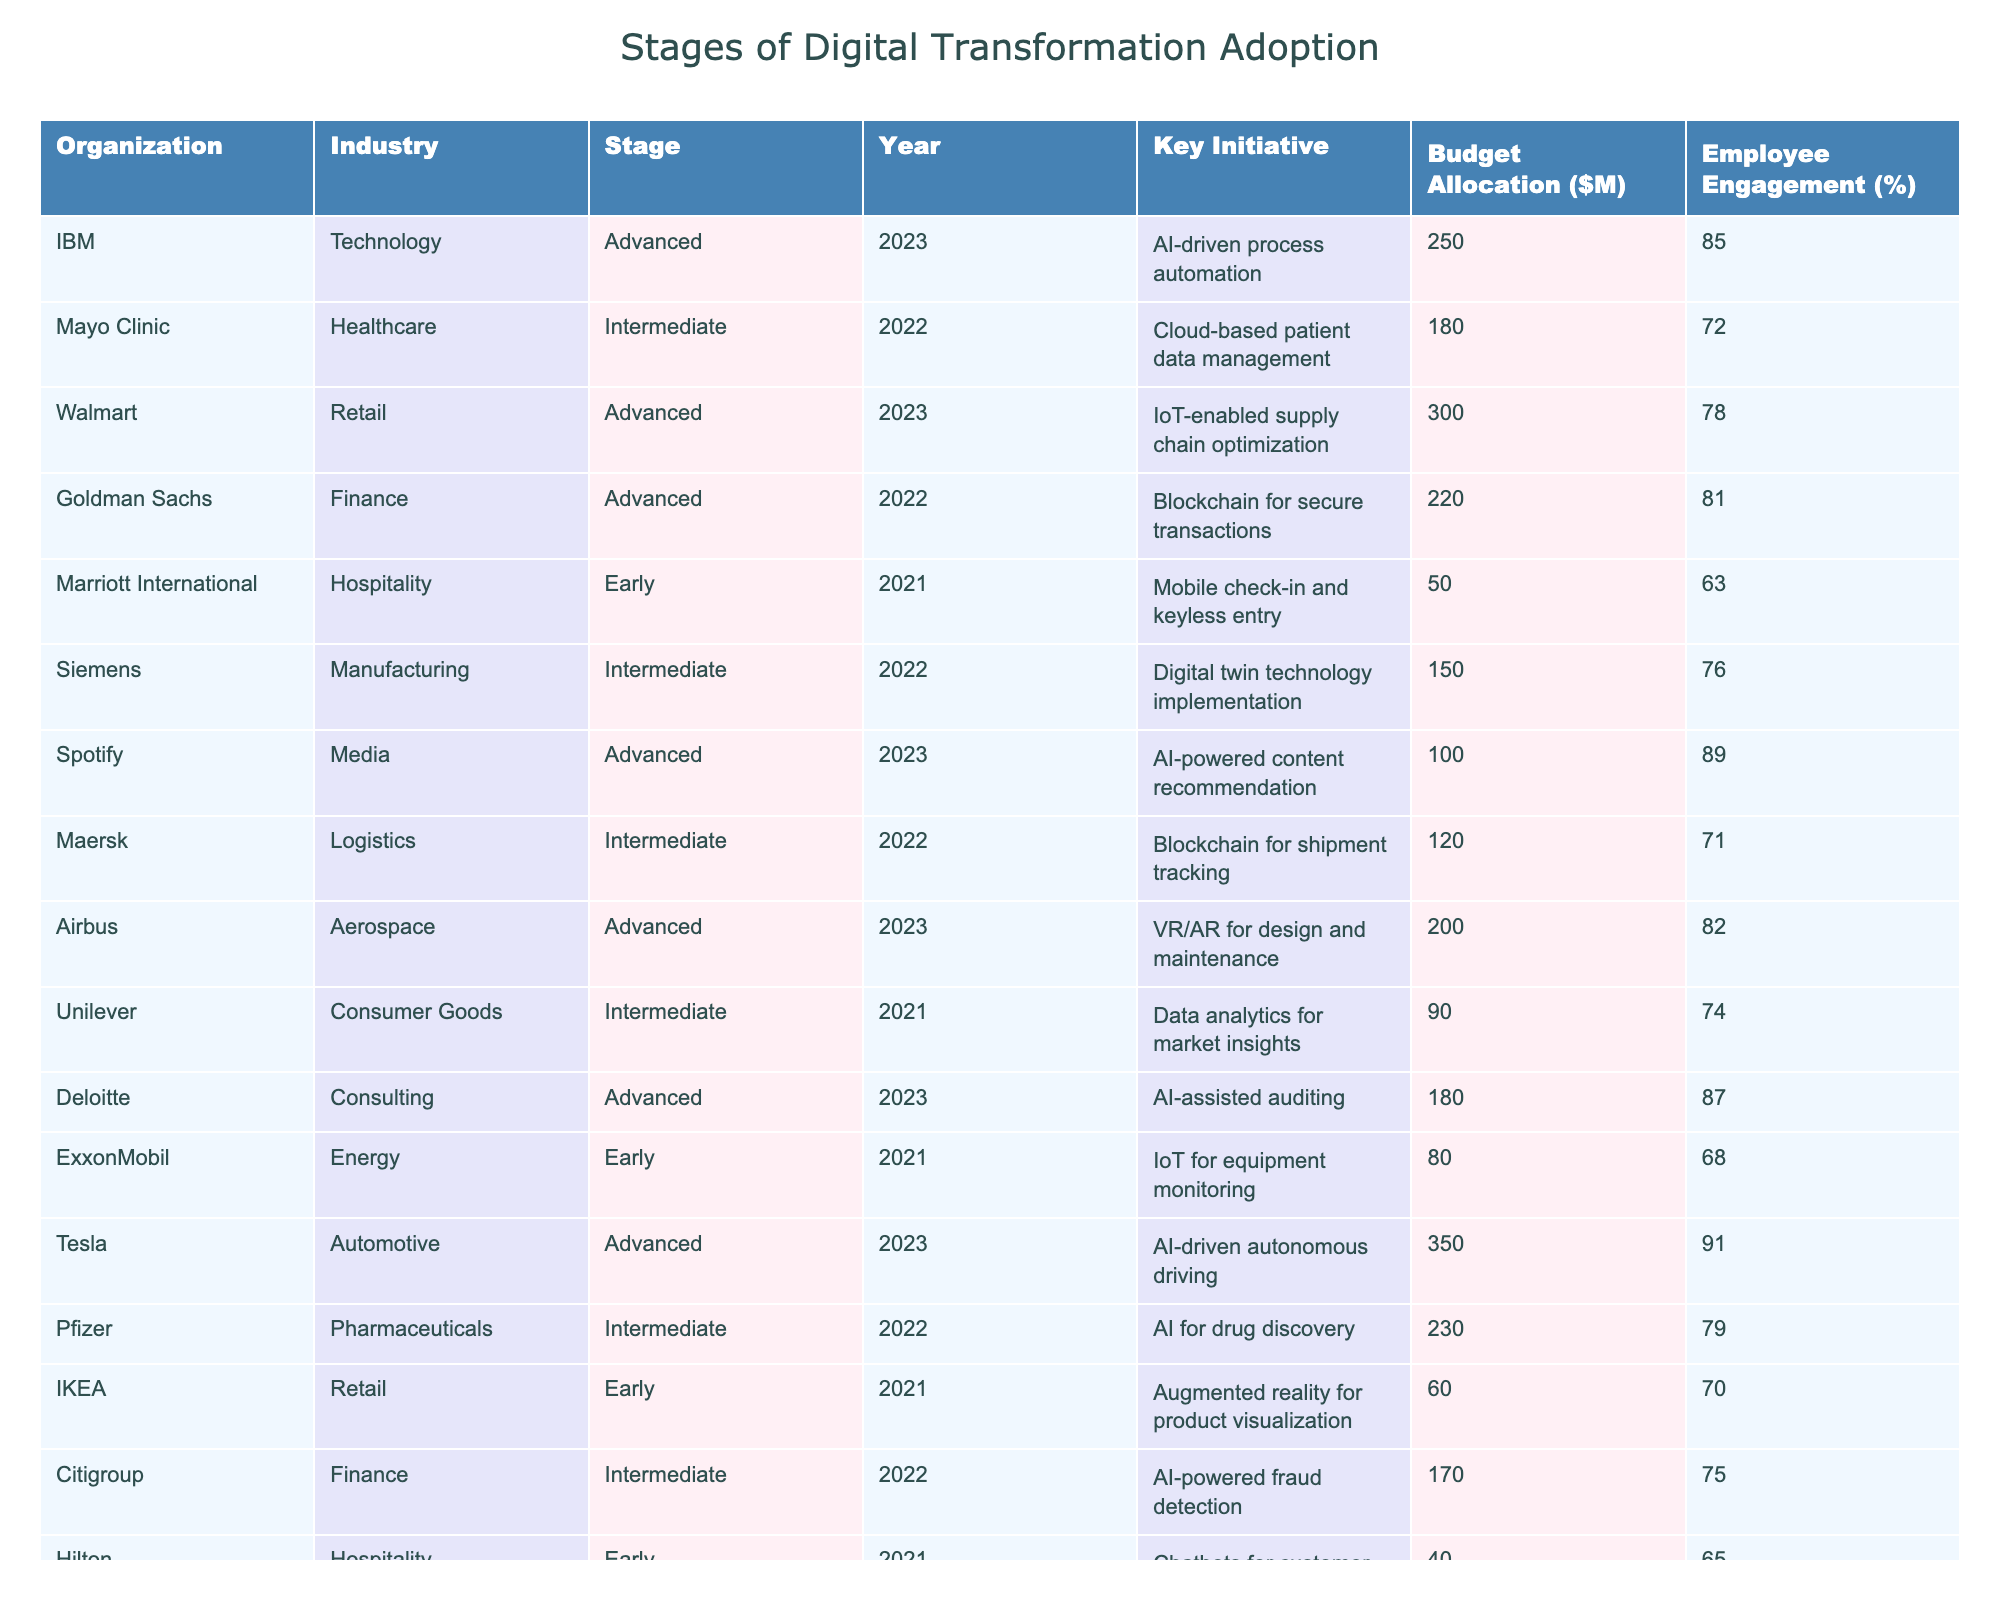What stage of digital transformation is IBM in? The table shows that IBM is classified under the "Advanced" stage of digital transformation adoption for the year 2023.
Answer: Advanced What key initiative is associated with Pfizer? According to the table, Pfizer's key initiative is "AI for drug discovery" and it falls under the Intermediate stage of digital transformation in 2022.
Answer: AI for drug discovery Which organization has the highest budget allocation for digital transformation in 2023? The table indicates that Tesla has the highest budget allocation of $350 million for their digital transformation initiative in 2023.
Answer: Tesla What is the average budget allocation across all organizations listed? To calculate the average, sum all budget allocations ($250M + $180M + ... + $280M = $1,525M) and divide by the total number of organizations (15). This results in an average budget allocation of $101.67 million.
Answer: 101.67 million Is there any organization in the Early stage of digital transformation with an employee engagement percentage above 70%? By checking the Early stage entries (Marriott International, ExxonMobil, IKEA, Hilton), we see that none have an employee engagement percentage exceeding 70%.
Answer: No What is the relationship between the stage of digital transformation and budget allocation based on this data? Analyzing the data, organizations in the Advanced stage tend to have higher budget allocations compared to those in Early and Intermediate stages, which indicates that advanced adopters are investing more in transformation initiatives.
Answer: Higher budget in Advanced stage Which industry has the most organizations in the Advanced stage? Looking through the table, the Technology and Finance industries each have three organizations in the Advanced stage.
Answer: Technology and Finance What is the median employee engagement percentage for organizations in the Intermediate stage? The employee engagement percentages for Intermediate stage organizations (72, 76, 71, 79, 75, 77) when sorted are 71, 72, 75, 76, 77, 79. The median of this set is the average of the middle two values (75 + 76) / 2 = 75.5.
Answer: 75.5 How many organizations in the Retail industry are in the Early stage? The table lists two organizations in the Retail industry (Walmart and IKEA), but only IKEA is in the Early stage.
Answer: One Which organization has the lowest employee engagement percentage and what is it? Upon reviewing the table, Hilton has the lowest employee engagement percentage at 65% in the Early stage of digital transformation.
Answer: 65% 